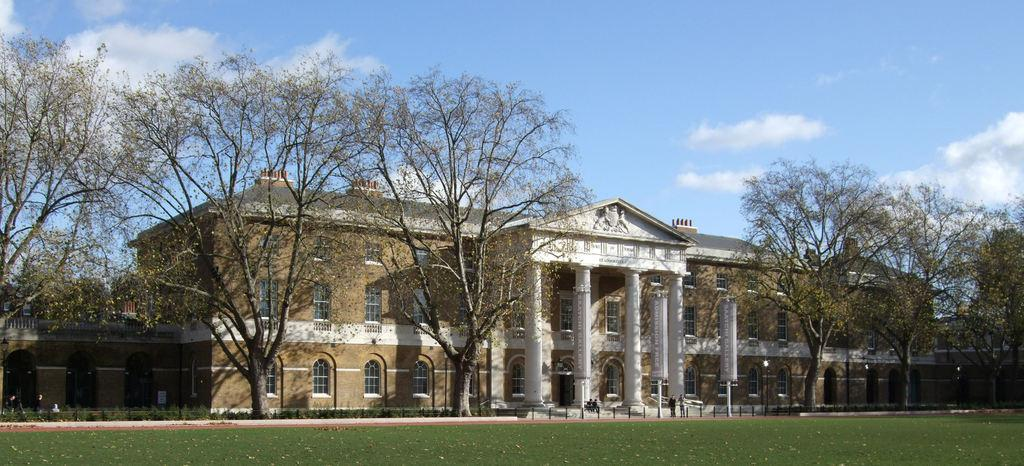What type of vegetation is at the bottom of the image? There is grass at the bottom of the image. What can be seen in the background of the image? There are trees, a fence, buildings, windows, people standing on the ground, light poles, and clouds visible in the background of the image. What type of haircut does the plant in the image have? There is no plant present in the image, and therefore no haircut can be observed. What type of voyage is depicted in the image? The image does not depict a voyage; it features a grassy area with various elements in the background. 